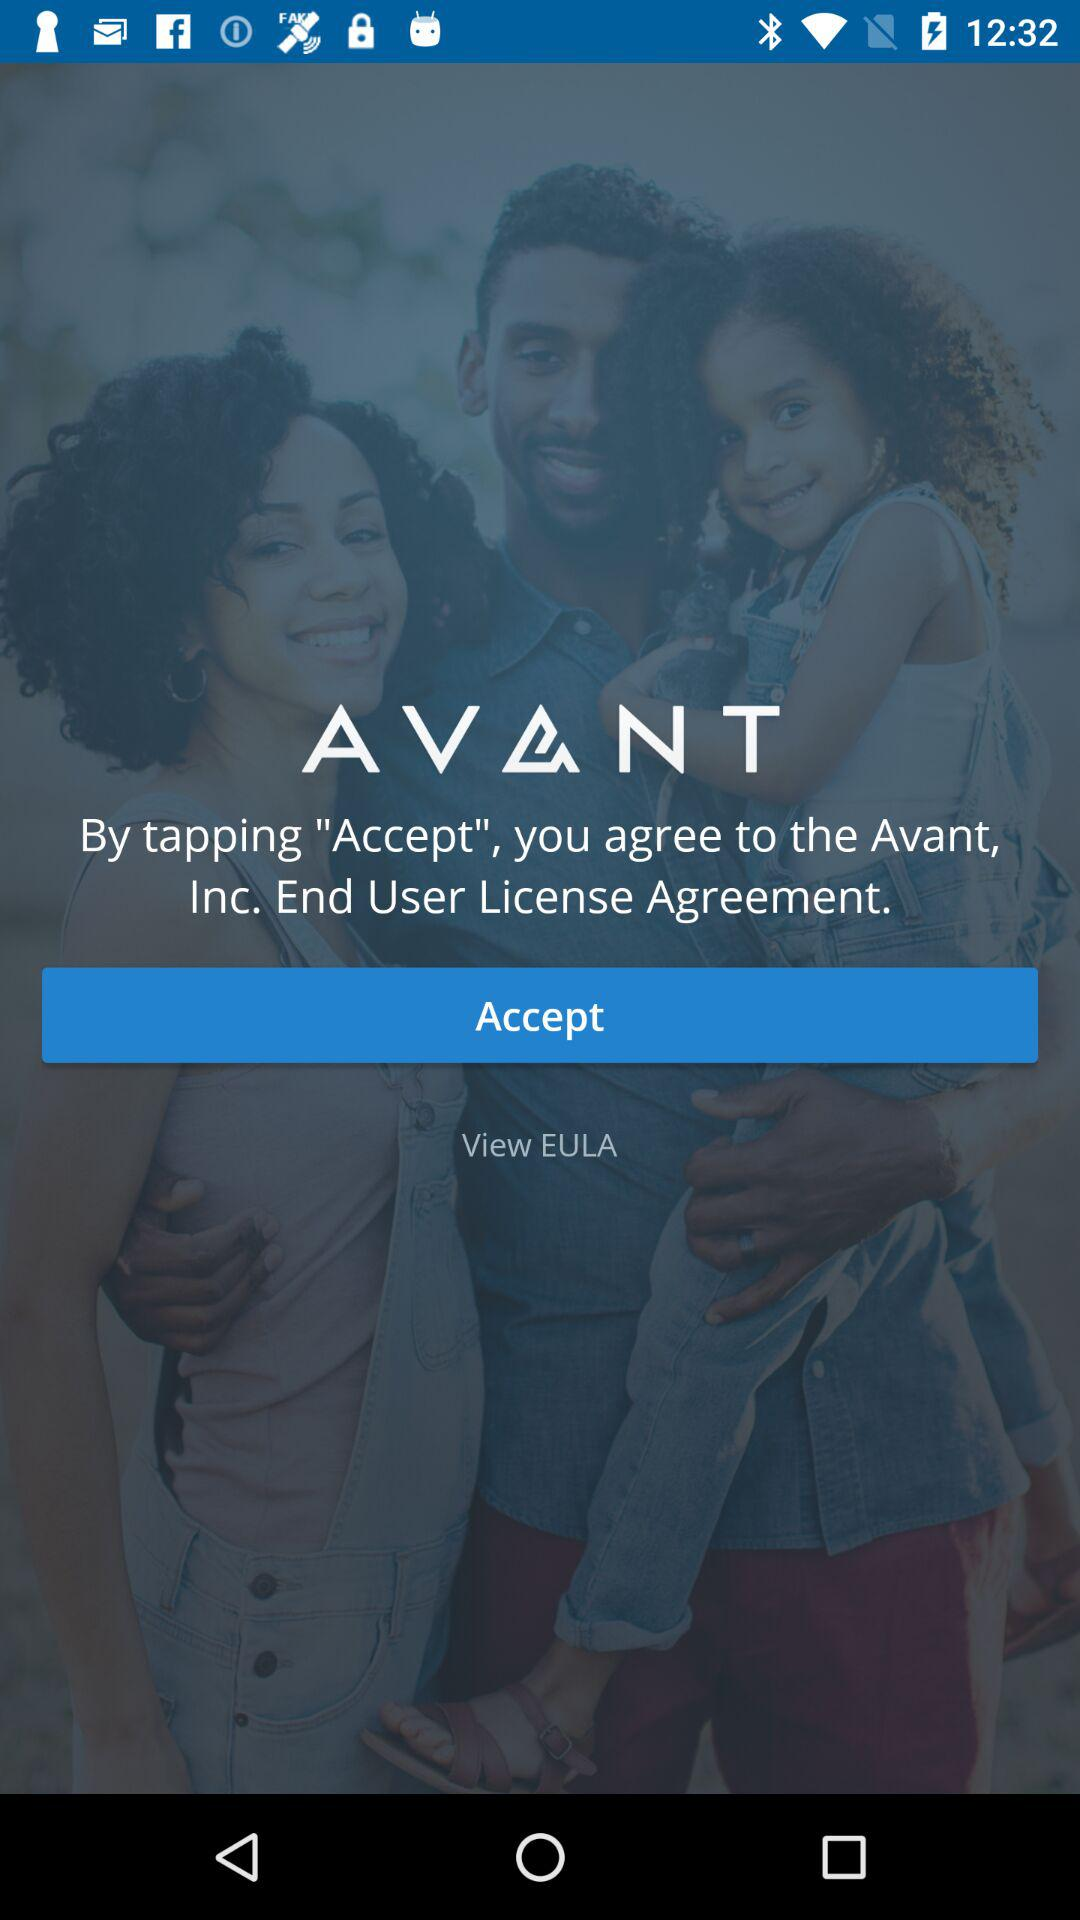What is the name of the application? The name of the application is "AVANT". 